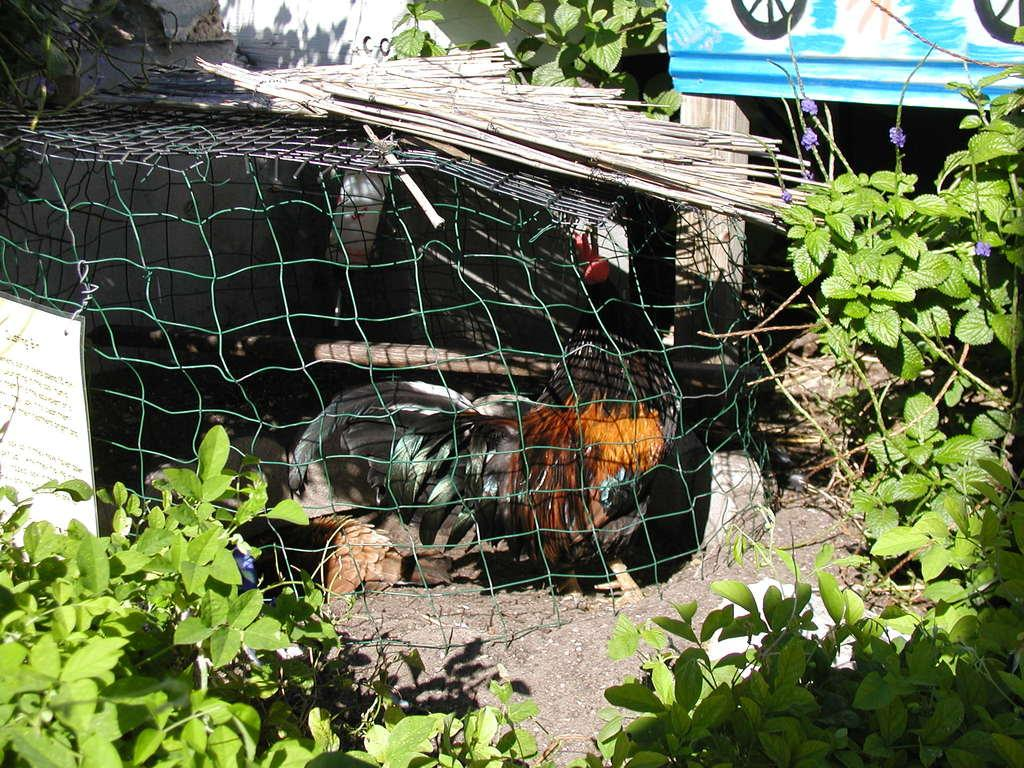What type of living organisms can be seen in the image? Plants are visible in the image. What kind of animal is present in the image? There is a black and brown color chicken in the image. What is the color of the board in the image? The board in the image is blue. What is the purpose of the paper in the image? Something is written on the paper, which suggests it might be used for communication or documentation. What type of prison is depicted in the image? There is no prison present in the image. Can you tell me which actor is holding the guitar in the image? There is no actor or guitar present in the image. 